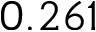Convert formula to latex. <formula><loc_0><loc_0><loc_500><loc_500>0 . 2 6 1</formula> 